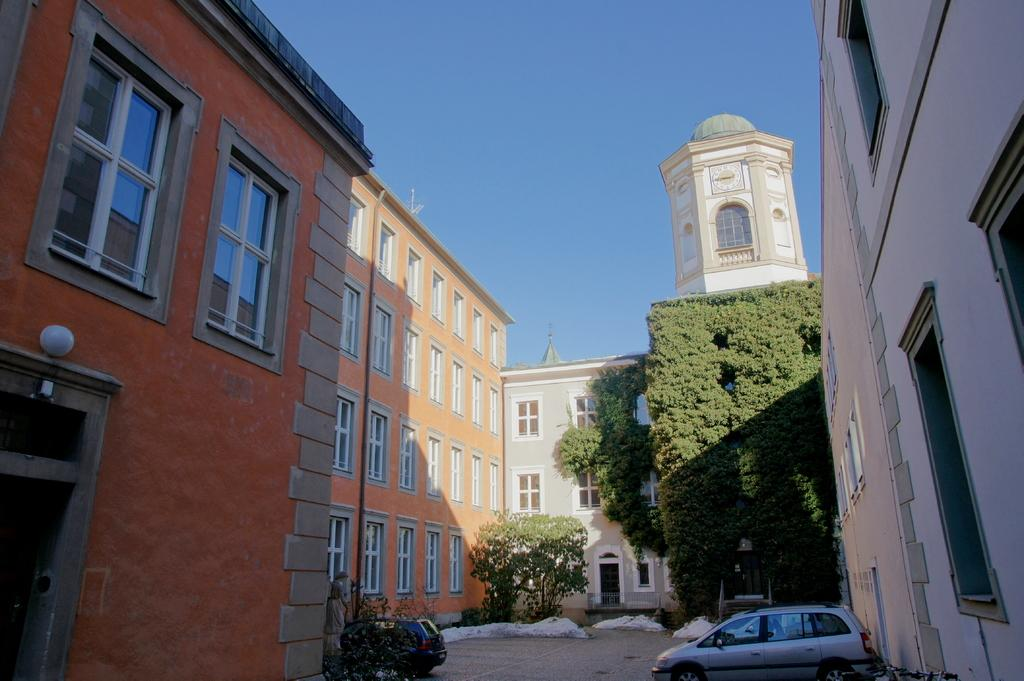What type of view is shown in the image? The image is an outside view. What vehicles can be seen on the ground in the image? There are two cars on the ground in the image. What structures are visible in the image? There are buildings visible in the image. What type of vegetation is present in the image? There are trees in the image. What is visible at the top of the image? The sky is visible at the top of the image, and its color is blue. What type of reaction can be seen from the pot in the image? There is no pot present in the image, so no reaction can be observed. 